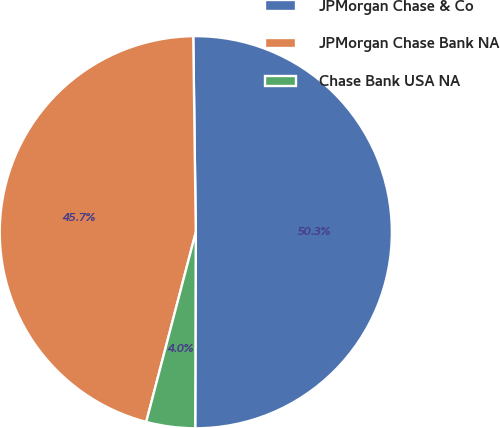Convert chart. <chart><loc_0><loc_0><loc_500><loc_500><pie_chart><fcel>JPMorgan Chase & Co<fcel>JPMorgan Chase Bank NA<fcel>Chase Bank USA NA<nl><fcel>50.25%<fcel>45.72%<fcel>4.02%<nl></chart> 